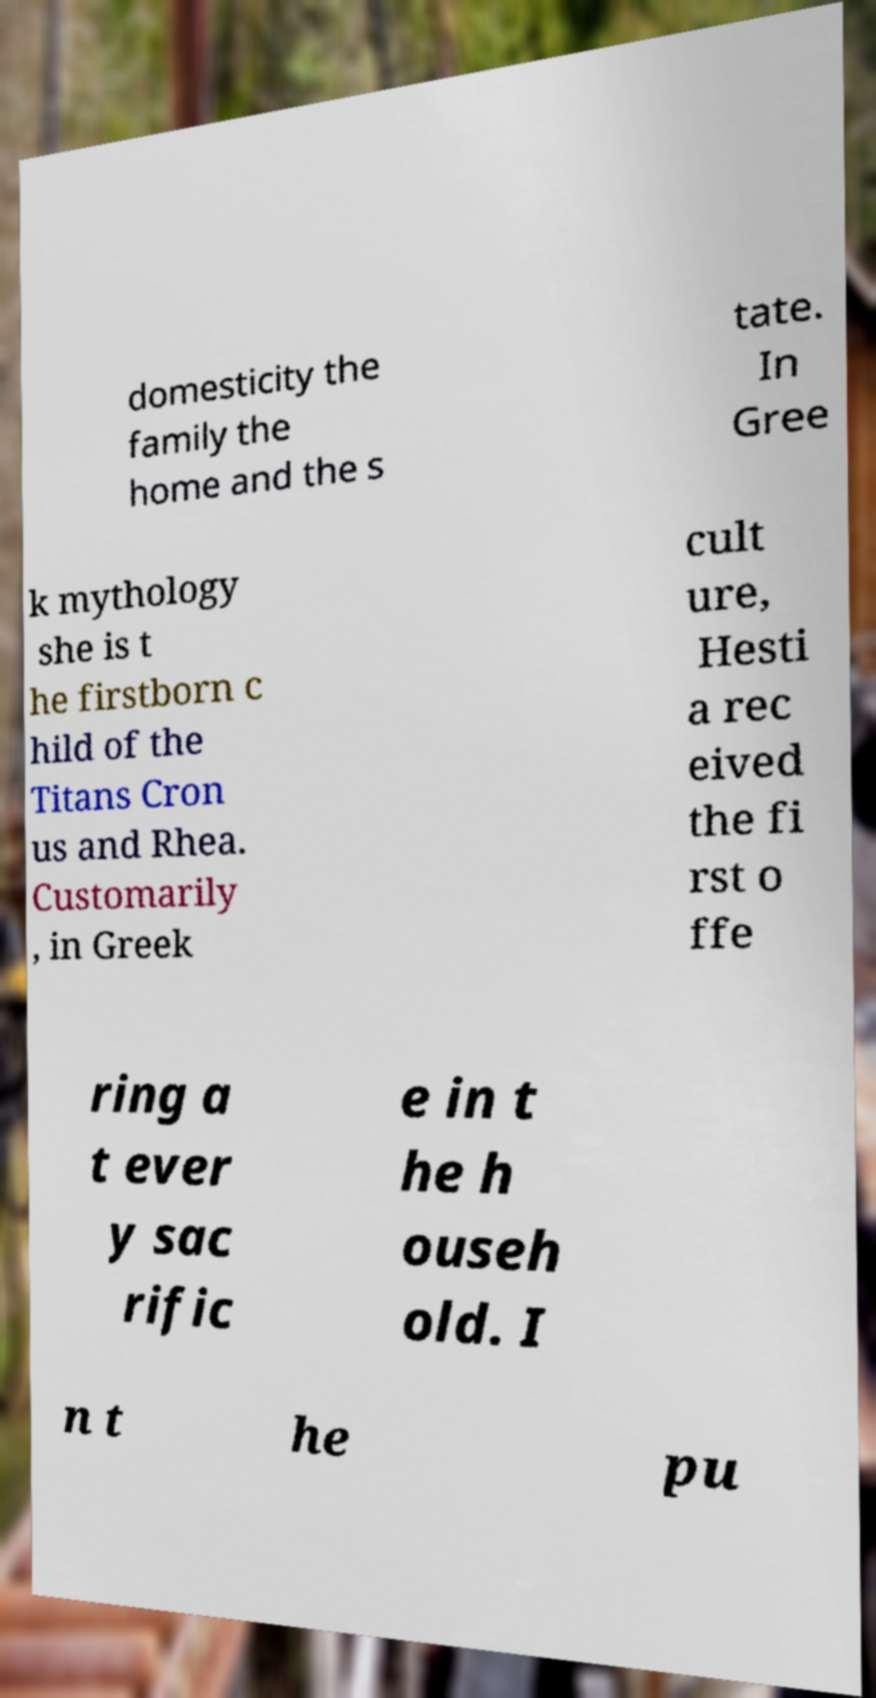Could you extract and type out the text from this image? domesticity the family the home and the s tate. In Gree k mythology she is t he firstborn c hild of the Titans Cron us and Rhea. Customarily , in Greek cult ure, Hesti a rec eived the fi rst o ffe ring a t ever y sac rific e in t he h ouseh old. I n t he pu 